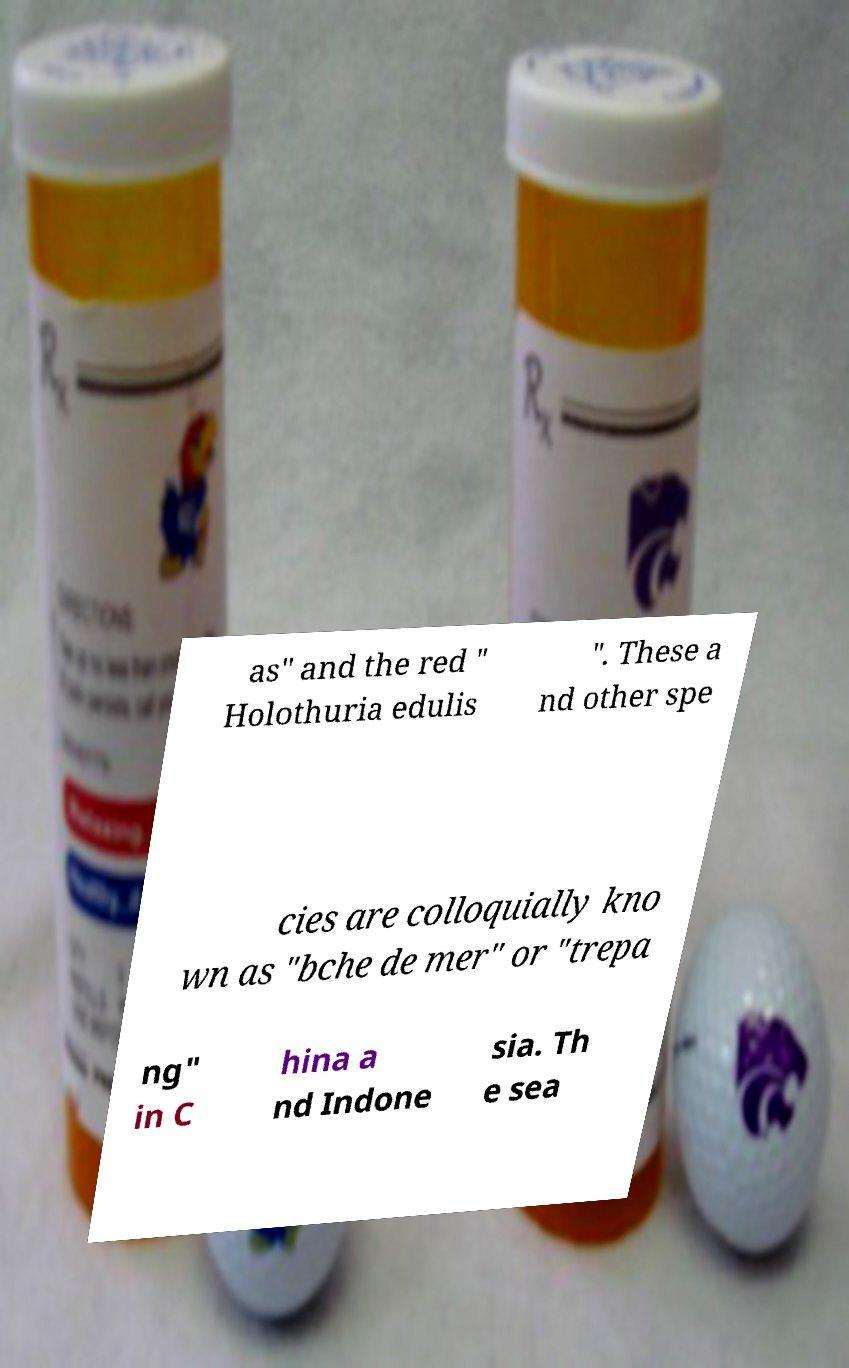Please identify and transcribe the text found in this image. as" and the red " Holothuria edulis ". These a nd other spe cies are colloquially kno wn as "bche de mer" or "trepa ng" in C hina a nd Indone sia. Th e sea 